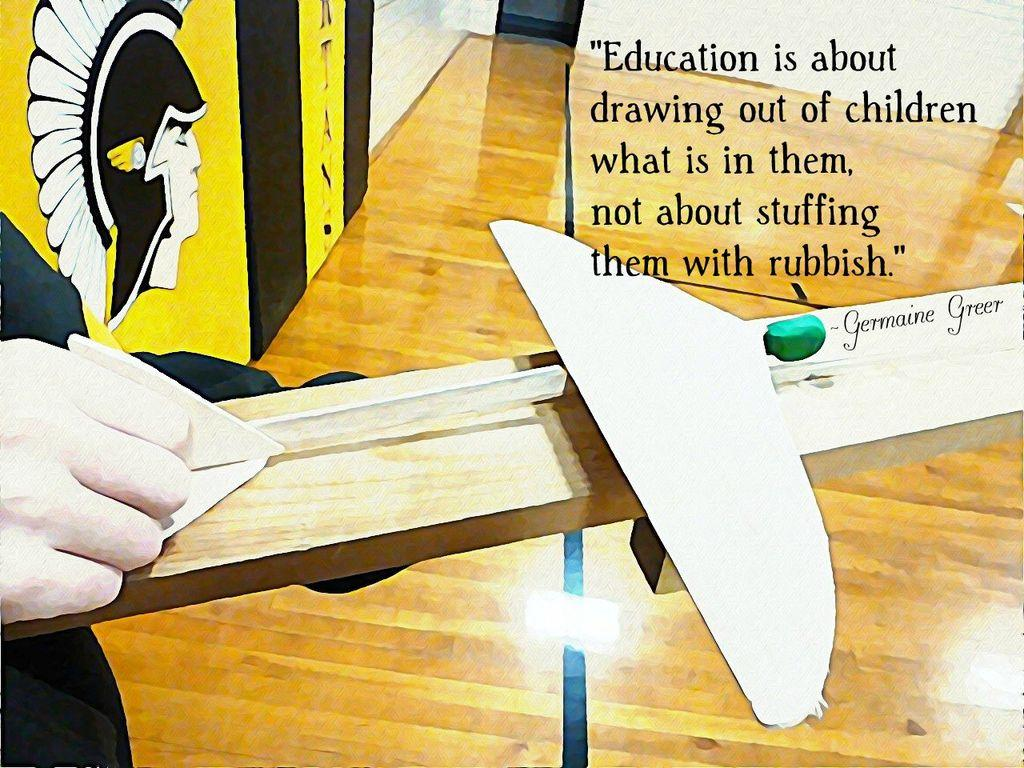<image>
Render a clear and concise summary of the photo. A person is holding a Germaine Greer model in their hand. 